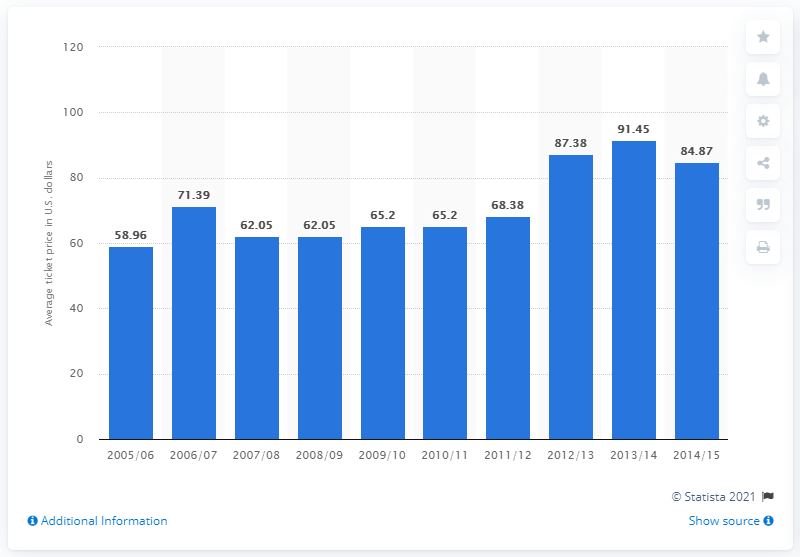Draw attention to some important aspects in this diagram. The average ticket price in the 2005/06 season was 58.96. 